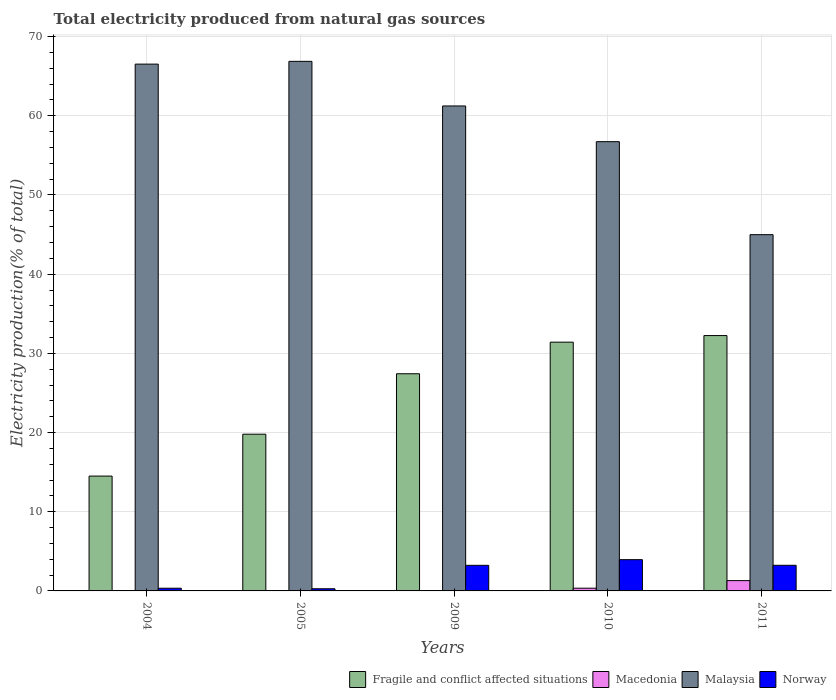How many different coloured bars are there?
Make the answer very short. 4. How many groups of bars are there?
Give a very brief answer. 5. How many bars are there on the 5th tick from the left?
Provide a short and direct response. 4. How many bars are there on the 5th tick from the right?
Your answer should be compact. 4. What is the label of the 5th group of bars from the left?
Provide a short and direct response. 2011. What is the total electricity produced in Norway in 2010?
Ensure brevity in your answer.  3.95. Across all years, what is the maximum total electricity produced in Fragile and conflict affected situations?
Ensure brevity in your answer.  32.25. Across all years, what is the minimum total electricity produced in Norway?
Your answer should be compact. 0.27. What is the total total electricity produced in Macedonia in the graph?
Ensure brevity in your answer.  1.71. What is the difference between the total electricity produced in Norway in 2005 and that in 2010?
Offer a very short reply. -3.67. What is the difference between the total electricity produced in Norway in 2011 and the total electricity produced in Macedonia in 2010?
Give a very brief answer. 2.89. What is the average total electricity produced in Norway per year?
Offer a terse response. 2.21. In the year 2010, what is the difference between the total electricity produced in Fragile and conflict affected situations and total electricity produced in Macedonia?
Your answer should be compact. 31.07. What is the ratio of the total electricity produced in Macedonia in 2009 to that in 2011?
Your answer should be very brief. 0.02. Is the total electricity produced in Macedonia in 2009 less than that in 2010?
Give a very brief answer. Yes. What is the difference between the highest and the second highest total electricity produced in Fragile and conflict affected situations?
Give a very brief answer. 0.83. What is the difference between the highest and the lowest total electricity produced in Norway?
Provide a short and direct response. 3.67. In how many years, is the total electricity produced in Fragile and conflict affected situations greater than the average total electricity produced in Fragile and conflict affected situations taken over all years?
Your response must be concise. 3. What does the 3rd bar from the left in 2005 represents?
Your answer should be compact. Malaysia. What does the 4th bar from the right in 2005 represents?
Keep it short and to the point. Fragile and conflict affected situations. How many years are there in the graph?
Provide a succinct answer. 5. Are the values on the major ticks of Y-axis written in scientific E-notation?
Your answer should be compact. No. Does the graph contain any zero values?
Provide a succinct answer. No. Does the graph contain grids?
Offer a terse response. Yes. How many legend labels are there?
Your answer should be compact. 4. What is the title of the graph?
Provide a short and direct response. Total electricity produced from natural gas sources. Does "Andorra" appear as one of the legend labels in the graph?
Offer a terse response. No. What is the label or title of the X-axis?
Offer a terse response. Years. What is the Electricity production(% of total) in Fragile and conflict affected situations in 2004?
Ensure brevity in your answer.  14.5. What is the Electricity production(% of total) in Macedonia in 2004?
Keep it short and to the point. 0.01. What is the Electricity production(% of total) in Malaysia in 2004?
Your response must be concise. 66.53. What is the Electricity production(% of total) of Norway in 2004?
Give a very brief answer. 0.34. What is the Electricity production(% of total) in Fragile and conflict affected situations in 2005?
Keep it short and to the point. 19.79. What is the Electricity production(% of total) of Macedonia in 2005?
Your answer should be very brief. 0.01. What is the Electricity production(% of total) of Malaysia in 2005?
Your answer should be compact. 66.87. What is the Electricity production(% of total) in Norway in 2005?
Your answer should be compact. 0.27. What is the Electricity production(% of total) of Fragile and conflict affected situations in 2009?
Offer a very short reply. 27.42. What is the Electricity production(% of total) of Macedonia in 2009?
Make the answer very short. 0.03. What is the Electricity production(% of total) of Malaysia in 2009?
Offer a very short reply. 61.24. What is the Electricity production(% of total) in Norway in 2009?
Give a very brief answer. 3.23. What is the Electricity production(% of total) in Fragile and conflict affected situations in 2010?
Provide a succinct answer. 31.41. What is the Electricity production(% of total) in Macedonia in 2010?
Make the answer very short. 0.34. What is the Electricity production(% of total) in Malaysia in 2010?
Offer a terse response. 56.73. What is the Electricity production(% of total) of Norway in 2010?
Offer a very short reply. 3.95. What is the Electricity production(% of total) of Fragile and conflict affected situations in 2011?
Ensure brevity in your answer.  32.25. What is the Electricity production(% of total) in Macedonia in 2011?
Your response must be concise. 1.3. What is the Electricity production(% of total) of Malaysia in 2011?
Your response must be concise. 44.99. What is the Electricity production(% of total) of Norway in 2011?
Give a very brief answer. 3.24. Across all years, what is the maximum Electricity production(% of total) of Fragile and conflict affected situations?
Offer a terse response. 32.25. Across all years, what is the maximum Electricity production(% of total) in Macedonia?
Offer a very short reply. 1.3. Across all years, what is the maximum Electricity production(% of total) in Malaysia?
Ensure brevity in your answer.  66.87. Across all years, what is the maximum Electricity production(% of total) in Norway?
Your response must be concise. 3.95. Across all years, what is the minimum Electricity production(% of total) in Fragile and conflict affected situations?
Your response must be concise. 14.5. Across all years, what is the minimum Electricity production(% of total) in Macedonia?
Ensure brevity in your answer.  0.01. Across all years, what is the minimum Electricity production(% of total) in Malaysia?
Your answer should be compact. 44.99. Across all years, what is the minimum Electricity production(% of total) of Norway?
Offer a terse response. 0.27. What is the total Electricity production(% of total) of Fragile and conflict affected situations in the graph?
Your response must be concise. 125.38. What is the total Electricity production(% of total) in Macedonia in the graph?
Offer a terse response. 1.71. What is the total Electricity production(% of total) in Malaysia in the graph?
Your response must be concise. 296.36. What is the total Electricity production(% of total) of Norway in the graph?
Provide a succinct answer. 11.03. What is the difference between the Electricity production(% of total) of Fragile and conflict affected situations in 2004 and that in 2005?
Provide a short and direct response. -5.29. What is the difference between the Electricity production(% of total) in Macedonia in 2004 and that in 2005?
Ensure brevity in your answer.  0. What is the difference between the Electricity production(% of total) in Malaysia in 2004 and that in 2005?
Provide a succinct answer. -0.35. What is the difference between the Electricity production(% of total) of Norway in 2004 and that in 2005?
Give a very brief answer. 0.07. What is the difference between the Electricity production(% of total) of Fragile and conflict affected situations in 2004 and that in 2009?
Offer a very short reply. -12.92. What is the difference between the Electricity production(% of total) of Macedonia in 2004 and that in 2009?
Keep it short and to the point. -0.01. What is the difference between the Electricity production(% of total) of Malaysia in 2004 and that in 2009?
Ensure brevity in your answer.  5.28. What is the difference between the Electricity production(% of total) in Norway in 2004 and that in 2009?
Provide a succinct answer. -2.89. What is the difference between the Electricity production(% of total) of Fragile and conflict affected situations in 2004 and that in 2010?
Offer a very short reply. -16.91. What is the difference between the Electricity production(% of total) of Macedonia in 2004 and that in 2010?
Offer a very short reply. -0.33. What is the difference between the Electricity production(% of total) in Malaysia in 2004 and that in 2010?
Your response must be concise. 9.79. What is the difference between the Electricity production(% of total) of Norway in 2004 and that in 2010?
Keep it short and to the point. -3.61. What is the difference between the Electricity production(% of total) in Fragile and conflict affected situations in 2004 and that in 2011?
Offer a very short reply. -17.74. What is the difference between the Electricity production(% of total) in Macedonia in 2004 and that in 2011?
Make the answer very short. -1.29. What is the difference between the Electricity production(% of total) of Malaysia in 2004 and that in 2011?
Your response must be concise. 21.54. What is the difference between the Electricity production(% of total) of Norway in 2004 and that in 2011?
Provide a succinct answer. -2.9. What is the difference between the Electricity production(% of total) of Fragile and conflict affected situations in 2005 and that in 2009?
Offer a terse response. -7.63. What is the difference between the Electricity production(% of total) in Macedonia in 2005 and that in 2009?
Your answer should be compact. -0.01. What is the difference between the Electricity production(% of total) in Malaysia in 2005 and that in 2009?
Give a very brief answer. 5.63. What is the difference between the Electricity production(% of total) of Norway in 2005 and that in 2009?
Provide a short and direct response. -2.96. What is the difference between the Electricity production(% of total) in Fragile and conflict affected situations in 2005 and that in 2010?
Ensure brevity in your answer.  -11.62. What is the difference between the Electricity production(% of total) of Macedonia in 2005 and that in 2010?
Give a very brief answer. -0.33. What is the difference between the Electricity production(% of total) of Malaysia in 2005 and that in 2010?
Provide a short and direct response. 10.14. What is the difference between the Electricity production(% of total) in Norway in 2005 and that in 2010?
Your response must be concise. -3.67. What is the difference between the Electricity production(% of total) of Fragile and conflict affected situations in 2005 and that in 2011?
Offer a very short reply. -12.46. What is the difference between the Electricity production(% of total) in Macedonia in 2005 and that in 2011?
Your response must be concise. -1.29. What is the difference between the Electricity production(% of total) in Malaysia in 2005 and that in 2011?
Give a very brief answer. 21.89. What is the difference between the Electricity production(% of total) of Norway in 2005 and that in 2011?
Your answer should be very brief. -2.96. What is the difference between the Electricity production(% of total) in Fragile and conflict affected situations in 2009 and that in 2010?
Make the answer very short. -3.99. What is the difference between the Electricity production(% of total) in Macedonia in 2009 and that in 2010?
Offer a terse response. -0.32. What is the difference between the Electricity production(% of total) of Malaysia in 2009 and that in 2010?
Your answer should be compact. 4.51. What is the difference between the Electricity production(% of total) of Norway in 2009 and that in 2010?
Your answer should be very brief. -0.72. What is the difference between the Electricity production(% of total) of Fragile and conflict affected situations in 2009 and that in 2011?
Your answer should be very brief. -4.82. What is the difference between the Electricity production(% of total) of Macedonia in 2009 and that in 2011?
Make the answer very short. -1.27. What is the difference between the Electricity production(% of total) in Malaysia in 2009 and that in 2011?
Your answer should be very brief. 16.25. What is the difference between the Electricity production(% of total) in Norway in 2009 and that in 2011?
Keep it short and to the point. -0. What is the difference between the Electricity production(% of total) of Fragile and conflict affected situations in 2010 and that in 2011?
Your answer should be compact. -0.83. What is the difference between the Electricity production(% of total) of Macedonia in 2010 and that in 2011?
Make the answer very short. -0.96. What is the difference between the Electricity production(% of total) in Malaysia in 2010 and that in 2011?
Keep it short and to the point. 11.74. What is the difference between the Electricity production(% of total) in Norway in 2010 and that in 2011?
Your answer should be compact. 0.71. What is the difference between the Electricity production(% of total) in Fragile and conflict affected situations in 2004 and the Electricity production(% of total) in Macedonia in 2005?
Your response must be concise. 14.49. What is the difference between the Electricity production(% of total) of Fragile and conflict affected situations in 2004 and the Electricity production(% of total) of Malaysia in 2005?
Keep it short and to the point. -52.37. What is the difference between the Electricity production(% of total) in Fragile and conflict affected situations in 2004 and the Electricity production(% of total) in Norway in 2005?
Ensure brevity in your answer.  14.23. What is the difference between the Electricity production(% of total) in Macedonia in 2004 and the Electricity production(% of total) in Malaysia in 2005?
Your response must be concise. -66.86. What is the difference between the Electricity production(% of total) of Macedonia in 2004 and the Electricity production(% of total) of Norway in 2005?
Provide a succinct answer. -0.26. What is the difference between the Electricity production(% of total) of Malaysia in 2004 and the Electricity production(% of total) of Norway in 2005?
Make the answer very short. 66.25. What is the difference between the Electricity production(% of total) of Fragile and conflict affected situations in 2004 and the Electricity production(% of total) of Macedonia in 2009?
Provide a succinct answer. 14.47. What is the difference between the Electricity production(% of total) in Fragile and conflict affected situations in 2004 and the Electricity production(% of total) in Malaysia in 2009?
Offer a very short reply. -46.74. What is the difference between the Electricity production(% of total) of Fragile and conflict affected situations in 2004 and the Electricity production(% of total) of Norway in 2009?
Provide a short and direct response. 11.27. What is the difference between the Electricity production(% of total) in Macedonia in 2004 and the Electricity production(% of total) in Malaysia in 2009?
Your answer should be very brief. -61.23. What is the difference between the Electricity production(% of total) in Macedonia in 2004 and the Electricity production(% of total) in Norway in 2009?
Offer a terse response. -3.22. What is the difference between the Electricity production(% of total) of Malaysia in 2004 and the Electricity production(% of total) of Norway in 2009?
Give a very brief answer. 63.29. What is the difference between the Electricity production(% of total) of Fragile and conflict affected situations in 2004 and the Electricity production(% of total) of Macedonia in 2010?
Your answer should be compact. 14.16. What is the difference between the Electricity production(% of total) of Fragile and conflict affected situations in 2004 and the Electricity production(% of total) of Malaysia in 2010?
Make the answer very short. -42.23. What is the difference between the Electricity production(% of total) in Fragile and conflict affected situations in 2004 and the Electricity production(% of total) in Norway in 2010?
Give a very brief answer. 10.55. What is the difference between the Electricity production(% of total) in Macedonia in 2004 and the Electricity production(% of total) in Malaysia in 2010?
Your answer should be compact. -56.72. What is the difference between the Electricity production(% of total) of Macedonia in 2004 and the Electricity production(% of total) of Norway in 2010?
Your response must be concise. -3.93. What is the difference between the Electricity production(% of total) of Malaysia in 2004 and the Electricity production(% of total) of Norway in 2010?
Offer a very short reply. 62.58. What is the difference between the Electricity production(% of total) of Fragile and conflict affected situations in 2004 and the Electricity production(% of total) of Macedonia in 2011?
Your response must be concise. 13.2. What is the difference between the Electricity production(% of total) in Fragile and conflict affected situations in 2004 and the Electricity production(% of total) in Malaysia in 2011?
Offer a very short reply. -30.49. What is the difference between the Electricity production(% of total) of Fragile and conflict affected situations in 2004 and the Electricity production(% of total) of Norway in 2011?
Keep it short and to the point. 11.26. What is the difference between the Electricity production(% of total) of Macedonia in 2004 and the Electricity production(% of total) of Malaysia in 2011?
Keep it short and to the point. -44.97. What is the difference between the Electricity production(% of total) in Macedonia in 2004 and the Electricity production(% of total) in Norway in 2011?
Keep it short and to the point. -3.22. What is the difference between the Electricity production(% of total) of Malaysia in 2004 and the Electricity production(% of total) of Norway in 2011?
Offer a very short reply. 63.29. What is the difference between the Electricity production(% of total) in Fragile and conflict affected situations in 2005 and the Electricity production(% of total) in Macedonia in 2009?
Keep it short and to the point. 19.76. What is the difference between the Electricity production(% of total) in Fragile and conflict affected situations in 2005 and the Electricity production(% of total) in Malaysia in 2009?
Keep it short and to the point. -41.45. What is the difference between the Electricity production(% of total) in Fragile and conflict affected situations in 2005 and the Electricity production(% of total) in Norway in 2009?
Your answer should be very brief. 16.56. What is the difference between the Electricity production(% of total) in Macedonia in 2005 and the Electricity production(% of total) in Malaysia in 2009?
Your response must be concise. -61.23. What is the difference between the Electricity production(% of total) of Macedonia in 2005 and the Electricity production(% of total) of Norway in 2009?
Your answer should be compact. -3.22. What is the difference between the Electricity production(% of total) in Malaysia in 2005 and the Electricity production(% of total) in Norway in 2009?
Offer a terse response. 63.64. What is the difference between the Electricity production(% of total) of Fragile and conflict affected situations in 2005 and the Electricity production(% of total) of Macedonia in 2010?
Ensure brevity in your answer.  19.45. What is the difference between the Electricity production(% of total) in Fragile and conflict affected situations in 2005 and the Electricity production(% of total) in Malaysia in 2010?
Your answer should be very brief. -36.94. What is the difference between the Electricity production(% of total) in Fragile and conflict affected situations in 2005 and the Electricity production(% of total) in Norway in 2010?
Offer a terse response. 15.84. What is the difference between the Electricity production(% of total) of Macedonia in 2005 and the Electricity production(% of total) of Malaysia in 2010?
Your answer should be compact. -56.72. What is the difference between the Electricity production(% of total) of Macedonia in 2005 and the Electricity production(% of total) of Norway in 2010?
Give a very brief answer. -3.93. What is the difference between the Electricity production(% of total) of Malaysia in 2005 and the Electricity production(% of total) of Norway in 2010?
Offer a terse response. 62.93. What is the difference between the Electricity production(% of total) in Fragile and conflict affected situations in 2005 and the Electricity production(% of total) in Macedonia in 2011?
Ensure brevity in your answer.  18.49. What is the difference between the Electricity production(% of total) in Fragile and conflict affected situations in 2005 and the Electricity production(% of total) in Malaysia in 2011?
Provide a short and direct response. -25.2. What is the difference between the Electricity production(% of total) of Fragile and conflict affected situations in 2005 and the Electricity production(% of total) of Norway in 2011?
Ensure brevity in your answer.  16.55. What is the difference between the Electricity production(% of total) in Macedonia in 2005 and the Electricity production(% of total) in Malaysia in 2011?
Offer a terse response. -44.97. What is the difference between the Electricity production(% of total) in Macedonia in 2005 and the Electricity production(% of total) in Norway in 2011?
Your answer should be very brief. -3.22. What is the difference between the Electricity production(% of total) in Malaysia in 2005 and the Electricity production(% of total) in Norway in 2011?
Ensure brevity in your answer.  63.64. What is the difference between the Electricity production(% of total) in Fragile and conflict affected situations in 2009 and the Electricity production(% of total) in Macedonia in 2010?
Your answer should be very brief. 27.08. What is the difference between the Electricity production(% of total) in Fragile and conflict affected situations in 2009 and the Electricity production(% of total) in Malaysia in 2010?
Provide a short and direct response. -29.31. What is the difference between the Electricity production(% of total) of Fragile and conflict affected situations in 2009 and the Electricity production(% of total) of Norway in 2010?
Keep it short and to the point. 23.48. What is the difference between the Electricity production(% of total) in Macedonia in 2009 and the Electricity production(% of total) in Malaysia in 2010?
Give a very brief answer. -56.7. What is the difference between the Electricity production(% of total) of Macedonia in 2009 and the Electricity production(% of total) of Norway in 2010?
Ensure brevity in your answer.  -3.92. What is the difference between the Electricity production(% of total) in Malaysia in 2009 and the Electricity production(% of total) in Norway in 2010?
Offer a terse response. 57.29. What is the difference between the Electricity production(% of total) in Fragile and conflict affected situations in 2009 and the Electricity production(% of total) in Macedonia in 2011?
Your answer should be very brief. 26.12. What is the difference between the Electricity production(% of total) in Fragile and conflict affected situations in 2009 and the Electricity production(% of total) in Malaysia in 2011?
Offer a terse response. -17.57. What is the difference between the Electricity production(% of total) of Fragile and conflict affected situations in 2009 and the Electricity production(% of total) of Norway in 2011?
Keep it short and to the point. 24.19. What is the difference between the Electricity production(% of total) in Macedonia in 2009 and the Electricity production(% of total) in Malaysia in 2011?
Give a very brief answer. -44.96. What is the difference between the Electricity production(% of total) in Macedonia in 2009 and the Electricity production(% of total) in Norway in 2011?
Offer a terse response. -3.21. What is the difference between the Electricity production(% of total) of Malaysia in 2009 and the Electricity production(% of total) of Norway in 2011?
Give a very brief answer. 58. What is the difference between the Electricity production(% of total) in Fragile and conflict affected situations in 2010 and the Electricity production(% of total) in Macedonia in 2011?
Give a very brief answer. 30.11. What is the difference between the Electricity production(% of total) in Fragile and conflict affected situations in 2010 and the Electricity production(% of total) in Malaysia in 2011?
Make the answer very short. -13.57. What is the difference between the Electricity production(% of total) in Fragile and conflict affected situations in 2010 and the Electricity production(% of total) in Norway in 2011?
Provide a succinct answer. 28.18. What is the difference between the Electricity production(% of total) of Macedonia in 2010 and the Electricity production(% of total) of Malaysia in 2011?
Provide a succinct answer. -44.64. What is the difference between the Electricity production(% of total) in Macedonia in 2010 and the Electricity production(% of total) in Norway in 2011?
Your answer should be compact. -2.89. What is the difference between the Electricity production(% of total) of Malaysia in 2010 and the Electricity production(% of total) of Norway in 2011?
Keep it short and to the point. 53.5. What is the average Electricity production(% of total) in Fragile and conflict affected situations per year?
Ensure brevity in your answer.  25.07. What is the average Electricity production(% of total) of Macedonia per year?
Keep it short and to the point. 0.34. What is the average Electricity production(% of total) of Malaysia per year?
Offer a very short reply. 59.27. What is the average Electricity production(% of total) of Norway per year?
Make the answer very short. 2.21. In the year 2004, what is the difference between the Electricity production(% of total) in Fragile and conflict affected situations and Electricity production(% of total) in Macedonia?
Offer a very short reply. 14.49. In the year 2004, what is the difference between the Electricity production(% of total) of Fragile and conflict affected situations and Electricity production(% of total) of Malaysia?
Provide a short and direct response. -52.02. In the year 2004, what is the difference between the Electricity production(% of total) of Fragile and conflict affected situations and Electricity production(% of total) of Norway?
Provide a short and direct response. 14.16. In the year 2004, what is the difference between the Electricity production(% of total) of Macedonia and Electricity production(% of total) of Malaysia?
Offer a very short reply. -66.51. In the year 2004, what is the difference between the Electricity production(% of total) of Macedonia and Electricity production(% of total) of Norway?
Your answer should be very brief. -0.32. In the year 2004, what is the difference between the Electricity production(% of total) of Malaysia and Electricity production(% of total) of Norway?
Offer a terse response. 66.19. In the year 2005, what is the difference between the Electricity production(% of total) of Fragile and conflict affected situations and Electricity production(% of total) of Macedonia?
Offer a terse response. 19.78. In the year 2005, what is the difference between the Electricity production(% of total) of Fragile and conflict affected situations and Electricity production(% of total) of Malaysia?
Your response must be concise. -47.08. In the year 2005, what is the difference between the Electricity production(% of total) in Fragile and conflict affected situations and Electricity production(% of total) in Norway?
Keep it short and to the point. 19.52. In the year 2005, what is the difference between the Electricity production(% of total) of Macedonia and Electricity production(% of total) of Malaysia?
Ensure brevity in your answer.  -66.86. In the year 2005, what is the difference between the Electricity production(% of total) in Macedonia and Electricity production(% of total) in Norway?
Offer a terse response. -0.26. In the year 2005, what is the difference between the Electricity production(% of total) in Malaysia and Electricity production(% of total) in Norway?
Make the answer very short. 66.6. In the year 2009, what is the difference between the Electricity production(% of total) of Fragile and conflict affected situations and Electricity production(% of total) of Macedonia?
Provide a succinct answer. 27.39. In the year 2009, what is the difference between the Electricity production(% of total) in Fragile and conflict affected situations and Electricity production(% of total) in Malaysia?
Your answer should be compact. -33.82. In the year 2009, what is the difference between the Electricity production(% of total) in Fragile and conflict affected situations and Electricity production(% of total) in Norway?
Keep it short and to the point. 24.19. In the year 2009, what is the difference between the Electricity production(% of total) of Macedonia and Electricity production(% of total) of Malaysia?
Your answer should be very brief. -61.21. In the year 2009, what is the difference between the Electricity production(% of total) in Macedonia and Electricity production(% of total) in Norway?
Give a very brief answer. -3.2. In the year 2009, what is the difference between the Electricity production(% of total) of Malaysia and Electricity production(% of total) of Norway?
Offer a very short reply. 58.01. In the year 2010, what is the difference between the Electricity production(% of total) in Fragile and conflict affected situations and Electricity production(% of total) in Macedonia?
Your response must be concise. 31.07. In the year 2010, what is the difference between the Electricity production(% of total) in Fragile and conflict affected situations and Electricity production(% of total) in Malaysia?
Your response must be concise. -25.32. In the year 2010, what is the difference between the Electricity production(% of total) of Fragile and conflict affected situations and Electricity production(% of total) of Norway?
Your answer should be very brief. 27.47. In the year 2010, what is the difference between the Electricity production(% of total) in Macedonia and Electricity production(% of total) in Malaysia?
Ensure brevity in your answer.  -56.39. In the year 2010, what is the difference between the Electricity production(% of total) in Macedonia and Electricity production(% of total) in Norway?
Your answer should be very brief. -3.6. In the year 2010, what is the difference between the Electricity production(% of total) in Malaysia and Electricity production(% of total) in Norway?
Provide a short and direct response. 52.79. In the year 2011, what is the difference between the Electricity production(% of total) in Fragile and conflict affected situations and Electricity production(% of total) in Macedonia?
Your response must be concise. 30.94. In the year 2011, what is the difference between the Electricity production(% of total) of Fragile and conflict affected situations and Electricity production(% of total) of Malaysia?
Your answer should be very brief. -12.74. In the year 2011, what is the difference between the Electricity production(% of total) of Fragile and conflict affected situations and Electricity production(% of total) of Norway?
Offer a very short reply. 29.01. In the year 2011, what is the difference between the Electricity production(% of total) of Macedonia and Electricity production(% of total) of Malaysia?
Provide a succinct answer. -43.69. In the year 2011, what is the difference between the Electricity production(% of total) in Macedonia and Electricity production(% of total) in Norway?
Ensure brevity in your answer.  -1.94. In the year 2011, what is the difference between the Electricity production(% of total) of Malaysia and Electricity production(% of total) of Norway?
Provide a short and direct response. 41.75. What is the ratio of the Electricity production(% of total) in Fragile and conflict affected situations in 2004 to that in 2005?
Give a very brief answer. 0.73. What is the ratio of the Electricity production(% of total) in Macedonia in 2004 to that in 2005?
Offer a very short reply. 1.04. What is the ratio of the Electricity production(% of total) of Malaysia in 2004 to that in 2005?
Provide a succinct answer. 0.99. What is the ratio of the Electricity production(% of total) of Norway in 2004 to that in 2005?
Give a very brief answer. 1.24. What is the ratio of the Electricity production(% of total) of Fragile and conflict affected situations in 2004 to that in 2009?
Give a very brief answer. 0.53. What is the ratio of the Electricity production(% of total) in Macedonia in 2004 to that in 2009?
Provide a succinct answer. 0.51. What is the ratio of the Electricity production(% of total) of Malaysia in 2004 to that in 2009?
Provide a short and direct response. 1.09. What is the ratio of the Electricity production(% of total) in Norway in 2004 to that in 2009?
Offer a very short reply. 0.11. What is the ratio of the Electricity production(% of total) of Fragile and conflict affected situations in 2004 to that in 2010?
Make the answer very short. 0.46. What is the ratio of the Electricity production(% of total) in Macedonia in 2004 to that in 2010?
Your answer should be compact. 0.04. What is the ratio of the Electricity production(% of total) in Malaysia in 2004 to that in 2010?
Give a very brief answer. 1.17. What is the ratio of the Electricity production(% of total) in Norway in 2004 to that in 2010?
Offer a terse response. 0.09. What is the ratio of the Electricity production(% of total) of Fragile and conflict affected situations in 2004 to that in 2011?
Your answer should be very brief. 0.45. What is the ratio of the Electricity production(% of total) of Macedonia in 2004 to that in 2011?
Give a very brief answer. 0.01. What is the ratio of the Electricity production(% of total) of Malaysia in 2004 to that in 2011?
Offer a very short reply. 1.48. What is the ratio of the Electricity production(% of total) in Norway in 2004 to that in 2011?
Provide a succinct answer. 0.1. What is the ratio of the Electricity production(% of total) in Fragile and conflict affected situations in 2005 to that in 2009?
Your answer should be very brief. 0.72. What is the ratio of the Electricity production(% of total) of Macedonia in 2005 to that in 2009?
Your answer should be very brief. 0.49. What is the ratio of the Electricity production(% of total) of Malaysia in 2005 to that in 2009?
Your answer should be very brief. 1.09. What is the ratio of the Electricity production(% of total) of Norway in 2005 to that in 2009?
Ensure brevity in your answer.  0.08. What is the ratio of the Electricity production(% of total) in Fragile and conflict affected situations in 2005 to that in 2010?
Your answer should be very brief. 0.63. What is the ratio of the Electricity production(% of total) of Macedonia in 2005 to that in 2010?
Keep it short and to the point. 0.04. What is the ratio of the Electricity production(% of total) in Malaysia in 2005 to that in 2010?
Offer a very short reply. 1.18. What is the ratio of the Electricity production(% of total) of Norway in 2005 to that in 2010?
Make the answer very short. 0.07. What is the ratio of the Electricity production(% of total) in Fragile and conflict affected situations in 2005 to that in 2011?
Give a very brief answer. 0.61. What is the ratio of the Electricity production(% of total) of Macedonia in 2005 to that in 2011?
Ensure brevity in your answer.  0.01. What is the ratio of the Electricity production(% of total) of Malaysia in 2005 to that in 2011?
Provide a short and direct response. 1.49. What is the ratio of the Electricity production(% of total) in Norway in 2005 to that in 2011?
Your answer should be very brief. 0.08. What is the ratio of the Electricity production(% of total) in Fragile and conflict affected situations in 2009 to that in 2010?
Make the answer very short. 0.87. What is the ratio of the Electricity production(% of total) in Macedonia in 2009 to that in 2010?
Your answer should be very brief. 0.09. What is the ratio of the Electricity production(% of total) of Malaysia in 2009 to that in 2010?
Ensure brevity in your answer.  1.08. What is the ratio of the Electricity production(% of total) of Norway in 2009 to that in 2010?
Offer a very short reply. 0.82. What is the ratio of the Electricity production(% of total) in Fragile and conflict affected situations in 2009 to that in 2011?
Your answer should be compact. 0.85. What is the ratio of the Electricity production(% of total) in Macedonia in 2009 to that in 2011?
Keep it short and to the point. 0.02. What is the ratio of the Electricity production(% of total) in Malaysia in 2009 to that in 2011?
Your answer should be compact. 1.36. What is the ratio of the Electricity production(% of total) of Fragile and conflict affected situations in 2010 to that in 2011?
Make the answer very short. 0.97. What is the ratio of the Electricity production(% of total) in Macedonia in 2010 to that in 2011?
Offer a terse response. 0.26. What is the ratio of the Electricity production(% of total) in Malaysia in 2010 to that in 2011?
Make the answer very short. 1.26. What is the ratio of the Electricity production(% of total) of Norway in 2010 to that in 2011?
Make the answer very short. 1.22. What is the difference between the highest and the second highest Electricity production(% of total) of Fragile and conflict affected situations?
Provide a short and direct response. 0.83. What is the difference between the highest and the second highest Electricity production(% of total) in Macedonia?
Your response must be concise. 0.96. What is the difference between the highest and the second highest Electricity production(% of total) in Malaysia?
Your answer should be very brief. 0.35. What is the difference between the highest and the second highest Electricity production(% of total) of Norway?
Your response must be concise. 0.71. What is the difference between the highest and the lowest Electricity production(% of total) in Fragile and conflict affected situations?
Provide a succinct answer. 17.74. What is the difference between the highest and the lowest Electricity production(% of total) in Macedonia?
Keep it short and to the point. 1.29. What is the difference between the highest and the lowest Electricity production(% of total) of Malaysia?
Offer a terse response. 21.89. What is the difference between the highest and the lowest Electricity production(% of total) of Norway?
Your answer should be very brief. 3.67. 